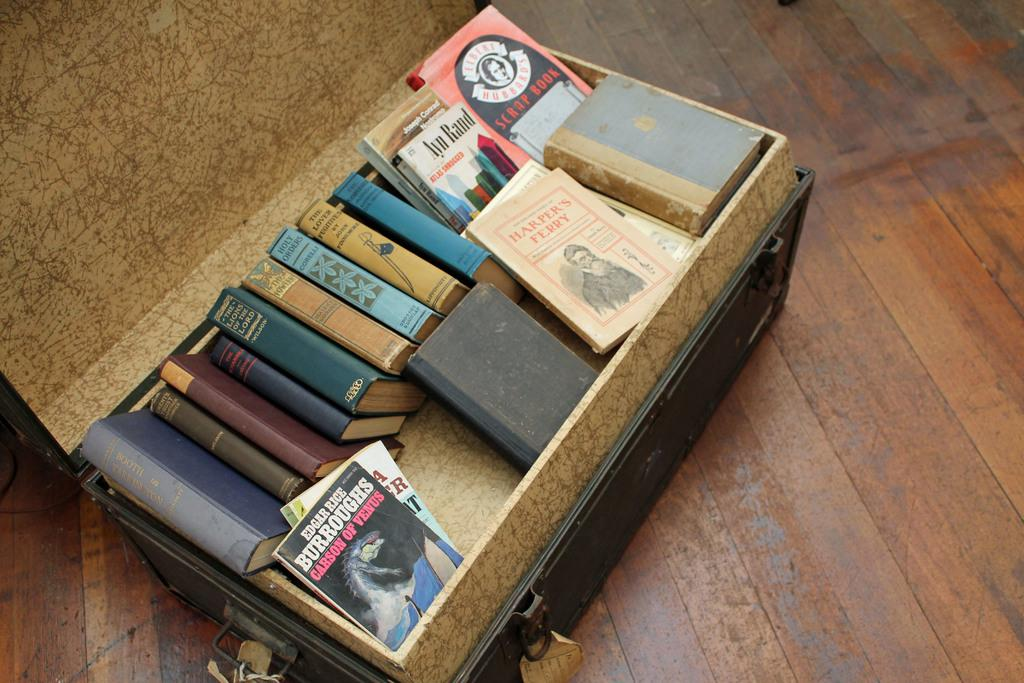Provide a one-sentence caption for the provided image. A chest full of books is displayed, one of which from the author Edgar Rice. 